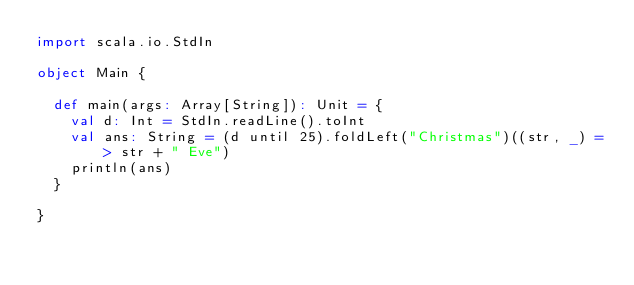<code> <loc_0><loc_0><loc_500><loc_500><_Scala_>import scala.io.StdIn

object Main {

  def main(args: Array[String]): Unit = {
    val d: Int = StdIn.readLine().toInt
    val ans: String = (d until 25).foldLeft("Christmas")((str, _) => str + " Eve")
    println(ans)
  }

}
</code> 